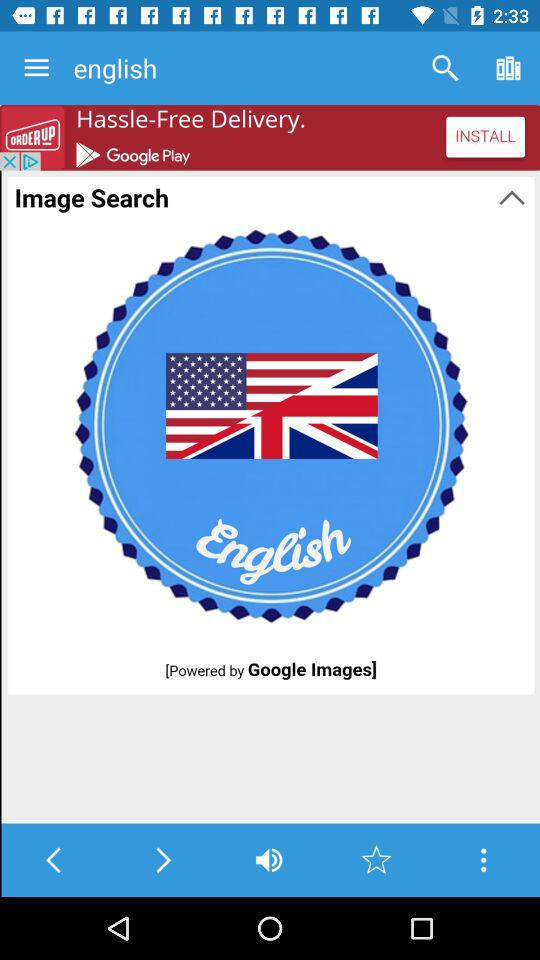By whom is the application powered? The application is powered by "Google Images". 